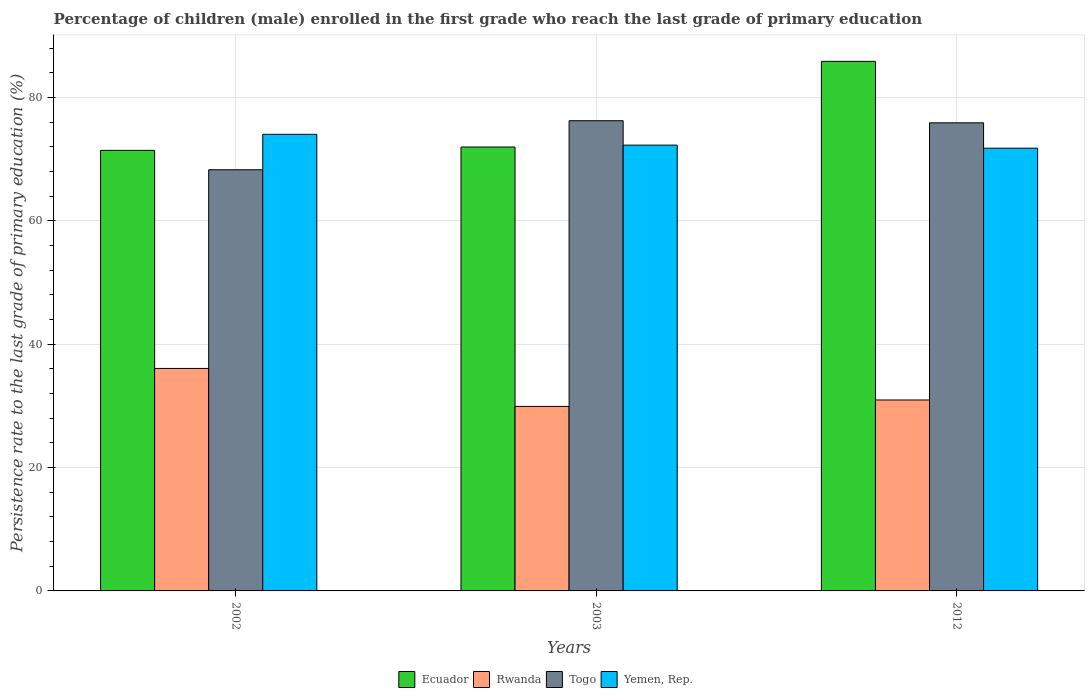How many different coloured bars are there?
Offer a very short reply. 4. How many groups of bars are there?
Provide a short and direct response. 3. Are the number of bars per tick equal to the number of legend labels?
Provide a succinct answer. Yes. Are the number of bars on each tick of the X-axis equal?
Your answer should be compact. Yes. How many bars are there on the 3rd tick from the left?
Give a very brief answer. 4. In how many cases, is the number of bars for a given year not equal to the number of legend labels?
Make the answer very short. 0. What is the persistence rate of children in Yemen, Rep. in 2002?
Ensure brevity in your answer.  74.05. Across all years, what is the maximum persistence rate of children in Togo?
Your response must be concise. 76.25. Across all years, what is the minimum persistence rate of children in Yemen, Rep.?
Offer a very short reply. 71.8. In which year was the persistence rate of children in Ecuador maximum?
Ensure brevity in your answer.  2012. In which year was the persistence rate of children in Rwanda minimum?
Your answer should be compact. 2003. What is the total persistence rate of children in Togo in the graph?
Your answer should be very brief. 220.47. What is the difference between the persistence rate of children in Rwanda in 2002 and that in 2003?
Your answer should be very brief. 6.16. What is the difference between the persistence rate of children in Yemen, Rep. in 2012 and the persistence rate of children in Togo in 2002?
Make the answer very short. 3.5. What is the average persistence rate of children in Yemen, Rep. per year?
Ensure brevity in your answer.  72.72. In the year 2012, what is the difference between the persistence rate of children in Yemen, Rep. and persistence rate of children in Togo?
Your response must be concise. -4.11. In how many years, is the persistence rate of children in Yemen, Rep. greater than 80 %?
Keep it short and to the point. 0. What is the ratio of the persistence rate of children in Togo in 2002 to that in 2003?
Offer a terse response. 0.9. Is the difference between the persistence rate of children in Yemen, Rep. in 2003 and 2012 greater than the difference between the persistence rate of children in Togo in 2003 and 2012?
Provide a succinct answer. Yes. What is the difference between the highest and the second highest persistence rate of children in Ecuador?
Your response must be concise. 13.89. What is the difference between the highest and the lowest persistence rate of children in Ecuador?
Offer a very short reply. 14.43. Is it the case that in every year, the sum of the persistence rate of children in Togo and persistence rate of children in Yemen, Rep. is greater than the sum of persistence rate of children in Rwanda and persistence rate of children in Ecuador?
Offer a terse response. No. What does the 4th bar from the left in 2003 represents?
Keep it short and to the point. Yemen, Rep. What does the 2nd bar from the right in 2012 represents?
Keep it short and to the point. Togo. How many bars are there?
Provide a short and direct response. 12. How many years are there in the graph?
Provide a short and direct response. 3. Does the graph contain any zero values?
Give a very brief answer. No. Does the graph contain grids?
Keep it short and to the point. Yes. Where does the legend appear in the graph?
Your response must be concise. Bottom center. How many legend labels are there?
Offer a very short reply. 4. How are the legend labels stacked?
Provide a short and direct response. Horizontal. What is the title of the graph?
Give a very brief answer. Percentage of children (male) enrolled in the first grade who reach the last grade of primary education. What is the label or title of the Y-axis?
Your answer should be compact. Persistence rate to the last grade of primary education (%). What is the Persistence rate to the last grade of primary education (%) of Ecuador in 2002?
Provide a succinct answer. 71.45. What is the Persistence rate to the last grade of primary education (%) in Rwanda in 2002?
Make the answer very short. 36.08. What is the Persistence rate to the last grade of primary education (%) of Togo in 2002?
Ensure brevity in your answer.  68.3. What is the Persistence rate to the last grade of primary education (%) of Yemen, Rep. in 2002?
Your answer should be very brief. 74.05. What is the Persistence rate to the last grade of primary education (%) in Ecuador in 2003?
Give a very brief answer. 71.99. What is the Persistence rate to the last grade of primary education (%) of Rwanda in 2003?
Give a very brief answer. 29.92. What is the Persistence rate to the last grade of primary education (%) in Togo in 2003?
Your answer should be very brief. 76.25. What is the Persistence rate to the last grade of primary education (%) of Yemen, Rep. in 2003?
Give a very brief answer. 72.3. What is the Persistence rate to the last grade of primary education (%) of Ecuador in 2012?
Give a very brief answer. 85.88. What is the Persistence rate to the last grade of primary education (%) of Rwanda in 2012?
Provide a short and direct response. 30.97. What is the Persistence rate to the last grade of primary education (%) in Togo in 2012?
Your answer should be very brief. 75.91. What is the Persistence rate to the last grade of primary education (%) in Yemen, Rep. in 2012?
Give a very brief answer. 71.8. Across all years, what is the maximum Persistence rate to the last grade of primary education (%) in Ecuador?
Ensure brevity in your answer.  85.88. Across all years, what is the maximum Persistence rate to the last grade of primary education (%) in Rwanda?
Provide a succinct answer. 36.08. Across all years, what is the maximum Persistence rate to the last grade of primary education (%) of Togo?
Provide a succinct answer. 76.25. Across all years, what is the maximum Persistence rate to the last grade of primary education (%) in Yemen, Rep.?
Give a very brief answer. 74.05. Across all years, what is the minimum Persistence rate to the last grade of primary education (%) of Ecuador?
Keep it short and to the point. 71.45. Across all years, what is the minimum Persistence rate to the last grade of primary education (%) in Rwanda?
Offer a very short reply. 29.92. Across all years, what is the minimum Persistence rate to the last grade of primary education (%) of Togo?
Ensure brevity in your answer.  68.3. Across all years, what is the minimum Persistence rate to the last grade of primary education (%) in Yemen, Rep.?
Provide a succinct answer. 71.8. What is the total Persistence rate to the last grade of primary education (%) of Ecuador in the graph?
Provide a succinct answer. 229.32. What is the total Persistence rate to the last grade of primary education (%) in Rwanda in the graph?
Make the answer very short. 96.97. What is the total Persistence rate to the last grade of primary education (%) in Togo in the graph?
Make the answer very short. 220.47. What is the total Persistence rate to the last grade of primary education (%) of Yemen, Rep. in the graph?
Offer a terse response. 218.15. What is the difference between the Persistence rate to the last grade of primary education (%) in Ecuador in 2002 and that in 2003?
Make the answer very short. -0.54. What is the difference between the Persistence rate to the last grade of primary education (%) of Rwanda in 2002 and that in 2003?
Ensure brevity in your answer.  6.16. What is the difference between the Persistence rate to the last grade of primary education (%) of Togo in 2002 and that in 2003?
Give a very brief answer. -7.95. What is the difference between the Persistence rate to the last grade of primary education (%) in Yemen, Rep. in 2002 and that in 2003?
Make the answer very short. 1.75. What is the difference between the Persistence rate to the last grade of primary education (%) in Ecuador in 2002 and that in 2012?
Your answer should be very brief. -14.43. What is the difference between the Persistence rate to the last grade of primary education (%) in Rwanda in 2002 and that in 2012?
Make the answer very short. 5.11. What is the difference between the Persistence rate to the last grade of primary education (%) of Togo in 2002 and that in 2012?
Keep it short and to the point. -7.61. What is the difference between the Persistence rate to the last grade of primary education (%) in Yemen, Rep. in 2002 and that in 2012?
Offer a very short reply. 2.25. What is the difference between the Persistence rate to the last grade of primary education (%) of Ecuador in 2003 and that in 2012?
Your answer should be compact. -13.89. What is the difference between the Persistence rate to the last grade of primary education (%) in Rwanda in 2003 and that in 2012?
Your answer should be very brief. -1.04. What is the difference between the Persistence rate to the last grade of primary education (%) of Togo in 2003 and that in 2012?
Your response must be concise. 0.34. What is the difference between the Persistence rate to the last grade of primary education (%) of Yemen, Rep. in 2003 and that in 2012?
Offer a terse response. 0.5. What is the difference between the Persistence rate to the last grade of primary education (%) in Ecuador in 2002 and the Persistence rate to the last grade of primary education (%) in Rwanda in 2003?
Give a very brief answer. 41.53. What is the difference between the Persistence rate to the last grade of primary education (%) in Ecuador in 2002 and the Persistence rate to the last grade of primary education (%) in Togo in 2003?
Your response must be concise. -4.81. What is the difference between the Persistence rate to the last grade of primary education (%) of Ecuador in 2002 and the Persistence rate to the last grade of primary education (%) of Yemen, Rep. in 2003?
Provide a succinct answer. -0.85. What is the difference between the Persistence rate to the last grade of primary education (%) in Rwanda in 2002 and the Persistence rate to the last grade of primary education (%) in Togo in 2003?
Make the answer very short. -40.17. What is the difference between the Persistence rate to the last grade of primary education (%) of Rwanda in 2002 and the Persistence rate to the last grade of primary education (%) of Yemen, Rep. in 2003?
Offer a terse response. -36.22. What is the difference between the Persistence rate to the last grade of primary education (%) of Togo in 2002 and the Persistence rate to the last grade of primary education (%) of Yemen, Rep. in 2003?
Give a very brief answer. -3.99. What is the difference between the Persistence rate to the last grade of primary education (%) of Ecuador in 2002 and the Persistence rate to the last grade of primary education (%) of Rwanda in 2012?
Your answer should be compact. 40.48. What is the difference between the Persistence rate to the last grade of primary education (%) of Ecuador in 2002 and the Persistence rate to the last grade of primary education (%) of Togo in 2012?
Ensure brevity in your answer.  -4.47. What is the difference between the Persistence rate to the last grade of primary education (%) of Ecuador in 2002 and the Persistence rate to the last grade of primary education (%) of Yemen, Rep. in 2012?
Your response must be concise. -0.35. What is the difference between the Persistence rate to the last grade of primary education (%) of Rwanda in 2002 and the Persistence rate to the last grade of primary education (%) of Togo in 2012?
Keep it short and to the point. -39.83. What is the difference between the Persistence rate to the last grade of primary education (%) of Rwanda in 2002 and the Persistence rate to the last grade of primary education (%) of Yemen, Rep. in 2012?
Provide a succinct answer. -35.72. What is the difference between the Persistence rate to the last grade of primary education (%) in Togo in 2002 and the Persistence rate to the last grade of primary education (%) in Yemen, Rep. in 2012?
Your response must be concise. -3.5. What is the difference between the Persistence rate to the last grade of primary education (%) in Ecuador in 2003 and the Persistence rate to the last grade of primary education (%) in Rwanda in 2012?
Offer a terse response. 41.02. What is the difference between the Persistence rate to the last grade of primary education (%) of Ecuador in 2003 and the Persistence rate to the last grade of primary education (%) of Togo in 2012?
Offer a very short reply. -3.93. What is the difference between the Persistence rate to the last grade of primary education (%) of Ecuador in 2003 and the Persistence rate to the last grade of primary education (%) of Yemen, Rep. in 2012?
Ensure brevity in your answer.  0.19. What is the difference between the Persistence rate to the last grade of primary education (%) in Rwanda in 2003 and the Persistence rate to the last grade of primary education (%) in Togo in 2012?
Your answer should be compact. -45.99. What is the difference between the Persistence rate to the last grade of primary education (%) in Rwanda in 2003 and the Persistence rate to the last grade of primary education (%) in Yemen, Rep. in 2012?
Your answer should be compact. -41.88. What is the difference between the Persistence rate to the last grade of primary education (%) of Togo in 2003 and the Persistence rate to the last grade of primary education (%) of Yemen, Rep. in 2012?
Your response must be concise. 4.45. What is the average Persistence rate to the last grade of primary education (%) of Ecuador per year?
Provide a succinct answer. 76.44. What is the average Persistence rate to the last grade of primary education (%) in Rwanda per year?
Keep it short and to the point. 32.32. What is the average Persistence rate to the last grade of primary education (%) in Togo per year?
Provide a short and direct response. 73.49. What is the average Persistence rate to the last grade of primary education (%) in Yemen, Rep. per year?
Provide a succinct answer. 72.72. In the year 2002, what is the difference between the Persistence rate to the last grade of primary education (%) of Ecuador and Persistence rate to the last grade of primary education (%) of Rwanda?
Your answer should be very brief. 35.37. In the year 2002, what is the difference between the Persistence rate to the last grade of primary education (%) of Ecuador and Persistence rate to the last grade of primary education (%) of Togo?
Ensure brevity in your answer.  3.14. In the year 2002, what is the difference between the Persistence rate to the last grade of primary education (%) of Ecuador and Persistence rate to the last grade of primary education (%) of Yemen, Rep.?
Make the answer very short. -2.6. In the year 2002, what is the difference between the Persistence rate to the last grade of primary education (%) of Rwanda and Persistence rate to the last grade of primary education (%) of Togo?
Ensure brevity in your answer.  -32.23. In the year 2002, what is the difference between the Persistence rate to the last grade of primary education (%) of Rwanda and Persistence rate to the last grade of primary education (%) of Yemen, Rep.?
Offer a terse response. -37.97. In the year 2002, what is the difference between the Persistence rate to the last grade of primary education (%) of Togo and Persistence rate to the last grade of primary education (%) of Yemen, Rep.?
Your answer should be very brief. -5.74. In the year 2003, what is the difference between the Persistence rate to the last grade of primary education (%) of Ecuador and Persistence rate to the last grade of primary education (%) of Rwanda?
Give a very brief answer. 42.07. In the year 2003, what is the difference between the Persistence rate to the last grade of primary education (%) of Ecuador and Persistence rate to the last grade of primary education (%) of Togo?
Give a very brief answer. -4.27. In the year 2003, what is the difference between the Persistence rate to the last grade of primary education (%) in Ecuador and Persistence rate to the last grade of primary education (%) in Yemen, Rep.?
Make the answer very short. -0.31. In the year 2003, what is the difference between the Persistence rate to the last grade of primary education (%) in Rwanda and Persistence rate to the last grade of primary education (%) in Togo?
Make the answer very short. -46.33. In the year 2003, what is the difference between the Persistence rate to the last grade of primary education (%) in Rwanda and Persistence rate to the last grade of primary education (%) in Yemen, Rep.?
Ensure brevity in your answer.  -42.38. In the year 2003, what is the difference between the Persistence rate to the last grade of primary education (%) of Togo and Persistence rate to the last grade of primary education (%) of Yemen, Rep.?
Your answer should be compact. 3.96. In the year 2012, what is the difference between the Persistence rate to the last grade of primary education (%) of Ecuador and Persistence rate to the last grade of primary education (%) of Rwanda?
Make the answer very short. 54.92. In the year 2012, what is the difference between the Persistence rate to the last grade of primary education (%) of Ecuador and Persistence rate to the last grade of primary education (%) of Togo?
Offer a very short reply. 9.97. In the year 2012, what is the difference between the Persistence rate to the last grade of primary education (%) of Ecuador and Persistence rate to the last grade of primary education (%) of Yemen, Rep.?
Give a very brief answer. 14.08. In the year 2012, what is the difference between the Persistence rate to the last grade of primary education (%) in Rwanda and Persistence rate to the last grade of primary education (%) in Togo?
Offer a terse response. -44.95. In the year 2012, what is the difference between the Persistence rate to the last grade of primary education (%) in Rwanda and Persistence rate to the last grade of primary education (%) in Yemen, Rep.?
Offer a very short reply. -40.83. In the year 2012, what is the difference between the Persistence rate to the last grade of primary education (%) of Togo and Persistence rate to the last grade of primary education (%) of Yemen, Rep.?
Your response must be concise. 4.11. What is the ratio of the Persistence rate to the last grade of primary education (%) in Rwanda in 2002 to that in 2003?
Your answer should be very brief. 1.21. What is the ratio of the Persistence rate to the last grade of primary education (%) of Togo in 2002 to that in 2003?
Give a very brief answer. 0.9. What is the ratio of the Persistence rate to the last grade of primary education (%) in Yemen, Rep. in 2002 to that in 2003?
Keep it short and to the point. 1.02. What is the ratio of the Persistence rate to the last grade of primary education (%) in Ecuador in 2002 to that in 2012?
Offer a terse response. 0.83. What is the ratio of the Persistence rate to the last grade of primary education (%) in Rwanda in 2002 to that in 2012?
Make the answer very short. 1.17. What is the ratio of the Persistence rate to the last grade of primary education (%) of Togo in 2002 to that in 2012?
Your answer should be very brief. 0.9. What is the ratio of the Persistence rate to the last grade of primary education (%) in Yemen, Rep. in 2002 to that in 2012?
Your answer should be compact. 1.03. What is the ratio of the Persistence rate to the last grade of primary education (%) of Ecuador in 2003 to that in 2012?
Offer a terse response. 0.84. What is the ratio of the Persistence rate to the last grade of primary education (%) in Rwanda in 2003 to that in 2012?
Your answer should be compact. 0.97. What is the ratio of the Persistence rate to the last grade of primary education (%) of Yemen, Rep. in 2003 to that in 2012?
Provide a short and direct response. 1.01. What is the difference between the highest and the second highest Persistence rate to the last grade of primary education (%) of Ecuador?
Give a very brief answer. 13.89. What is the difference between the highest and the second highest Persistence rate to the last grade of primary education (%) of Rwanda?
Make the answer very short. 5.11. What is the difference between the highest and the second highest Persistence rate to the last grade of primary education (%) in Togo?
Keep it short and to the point. 0.34. What is the difference between the highest and the second highest Persistence rate to the last grade of primary education (%) in Yemen, Rep.?
Provide a succinct answer. 1.75. What is the difference between the highest and the lowest Persistence rate to the last grade of primary education (%) in Ecuador?
Offer a terse response. 14.43. What is the difference between the highest and the lowest Persistence rate to the last grade of primary education (%) of Rwanda?
Offer a terse response. 6.16. What is the difference between the highest and the lowest Persistence rate to the last grade of primary education (%) in Togo?
Give a very brief answer. 7.95. What is the difference between the highest and the lowest Persistence rate to the last grade of primary education (%) in Yemen, Rep.?
Your answer should be very brief. 2.25. 